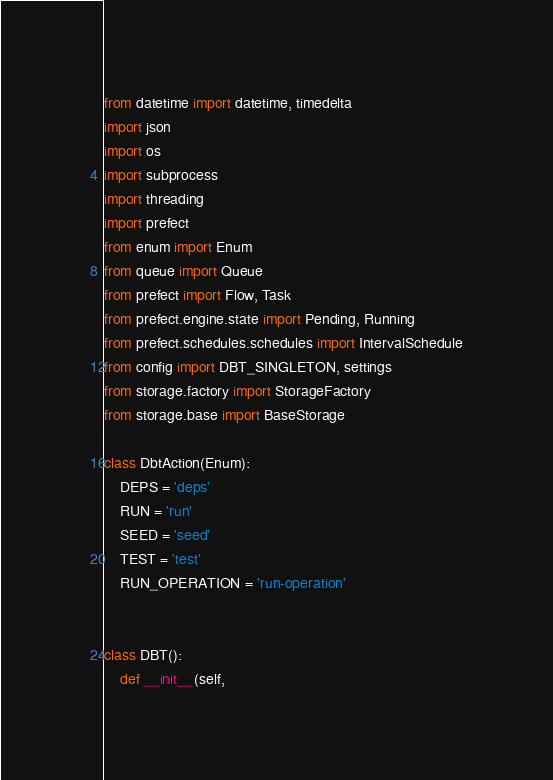Convert code to text. <code><loc_0><loc_0><loc_500><loc_500><_Python_>from datetime import datetime, timedelta
import json
import os
import subprocess
import threading
import prefect
from enum import Enum
from queue import Queue
from prefect import Flow, Task
from prefect.engine.state import Pending, Running
from prefect.schedules.schedules import IntervalSchedule
from config import DBT_SINGLETON, settings
from storage.factory import StorageFactory
from storage.base import BaseStorage

class DbtAction(Enum):
    DEPS = 'deps'
    RUN = 'run'
    SEED = 'seed'
    TEST = 'test'
    RUN_OPERATION = 'run-operation'


class DBT():
    def __init__(self,</code> 